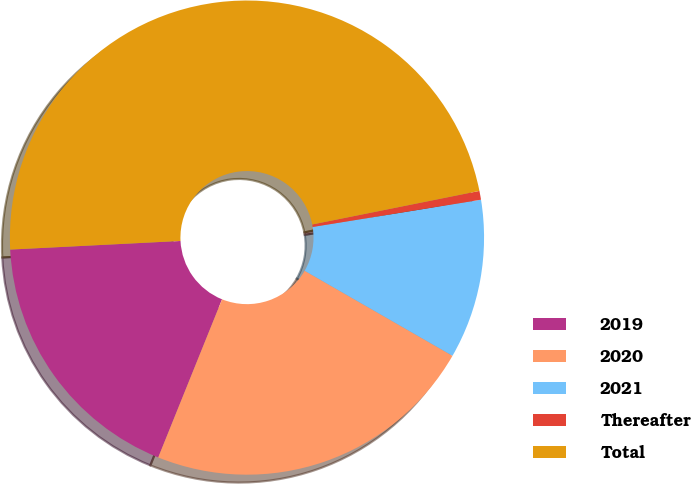<chart> <loc_0><loc_0><loc_500><loc_500><pie_chart><fcel>2019<fcel>2020<fcel>2021<fcel>Thereafter<fcel>Total<nl><fcel>18.09%<fcel>22.8%<fcel>10.86%<fcel>0.6%<fcel>47.65%<nl></chart> 